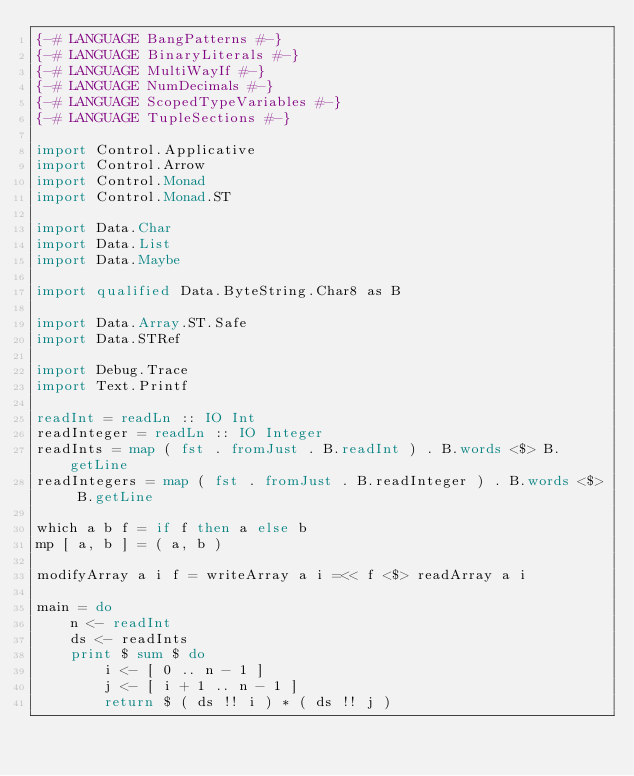Convert code to text. <code><loc_0><loc_0><loc_500><loc_500><_Haskell_>{-# LANGUAGE BangPatterns #-}
{-# LANGUAGE BinaryLiterals #-}
{-# LANGUAGE MultiWayIf #-}
{-# LANGUAGE NumDecimals #-}
{-# LANGUAGE ScopedTypeVariables #-}
{-# LANGUAGE TupleSections #-}

import Control.Applicative
import Control.Arrow
import Control.Monad
import Control.Monad.ST

import Data.Char
import Data.List
import Data.Maybe

import qualified Data.ByteString.Char8 as B

import Data.Array.ST.Safe
import Data.STRef

import Debug.Trace
import Text.Printf

readInt = readLn :: IO Int
readInteger = readLn :: IO Integer
readInts = map ( fst . fromJust . B.readInt ) . B.words <$> B.getLine
readIntegers = map ( fst . fromJust . B.readInteger ) . B.words <$> B.getLine

which a b f = if f then a else b
mp [ a, b ] = ( a, b )

modifyArray a i f = writeArray a i =<< f <$> readArray a i

main = do
	n <- readInt
	ds <- readInts
	print $ sum $ do
		i <- [ 0 .. n - 1 ]
		j <- [ i + 1 .. n - 1 ]
		return $ ( ds !! i ) * ( ds !! j )</code> 